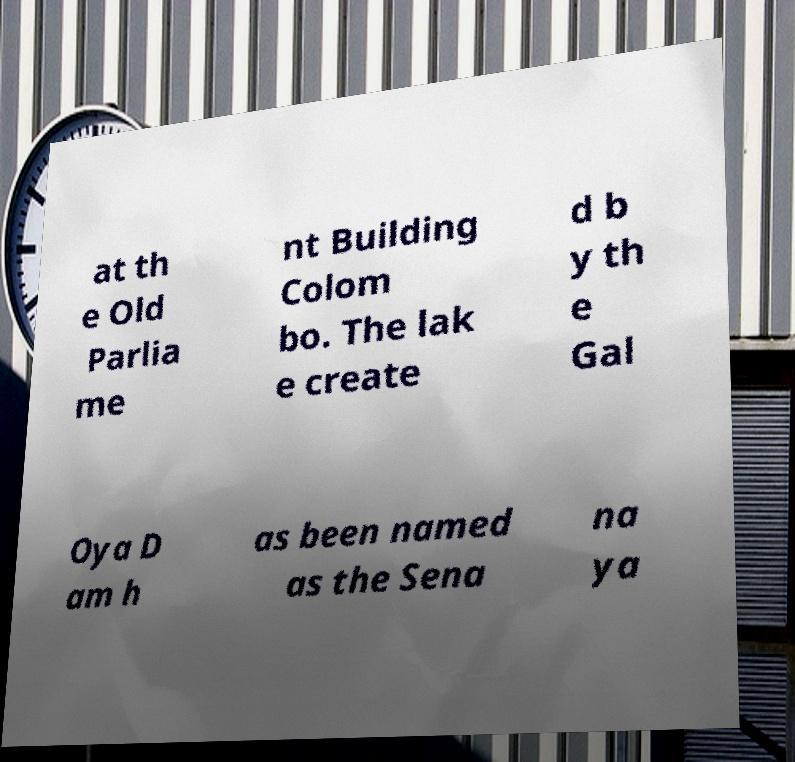Could you extract and type out the text from this image? at th e Old Parlia me nt Building Colom bo. The lak e create d b y th e Gal Oya D am h as been named as the Sena na ya 